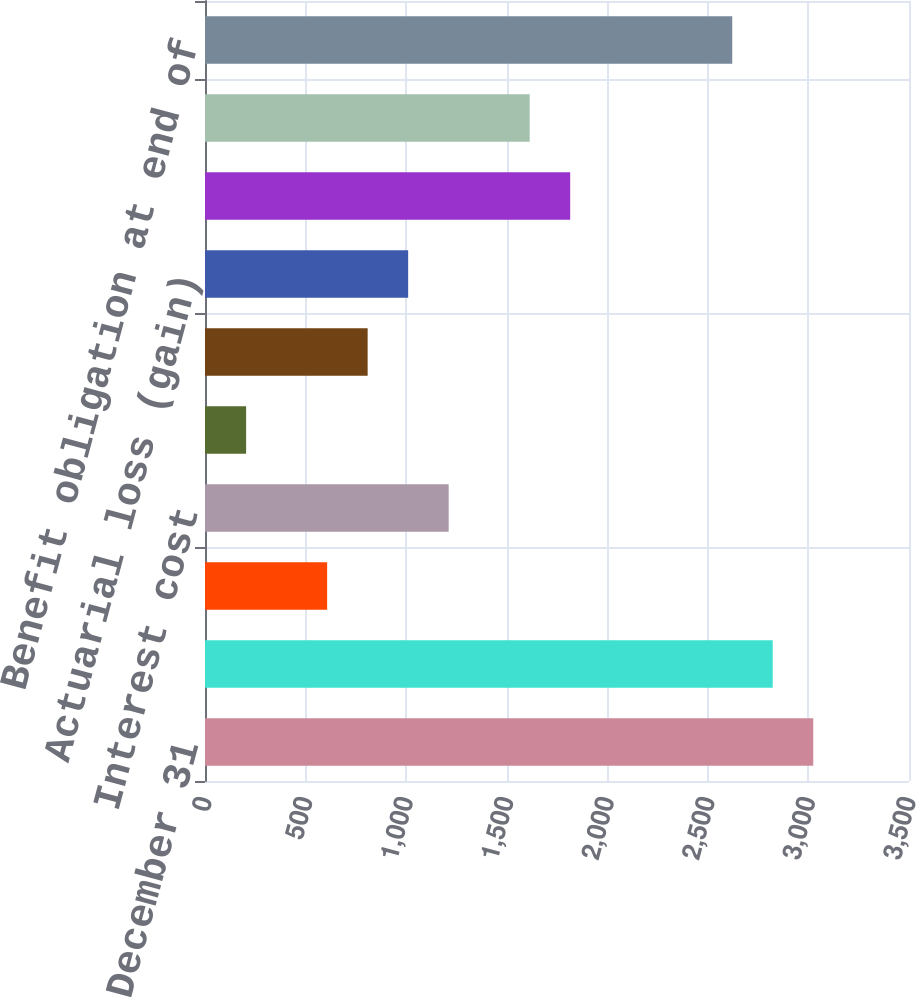<chart> <loc_0><loc_0><loc_500><loc_500><bar_chart><fcel>Year Ended December 31<fcel>Benefit obligation at<fcel>Service cost<fcel>Interest cost<fcel>Foreign currency exchange rate<fcel>Amendments<fcel>Actuarial loss (gain)<fcel>Benefits paid 2<fcel>Divestitures 3<fcel>Benefit obligation at end of<nl><fcel>3024<fcel>2822.6<fcel>607.2<fcel>1211.4<fcel>204.4<fcel>808.6<fcel>1010<fcel>1815.6<fcel>1614.2<fcel>2621.2<nl></chart> 